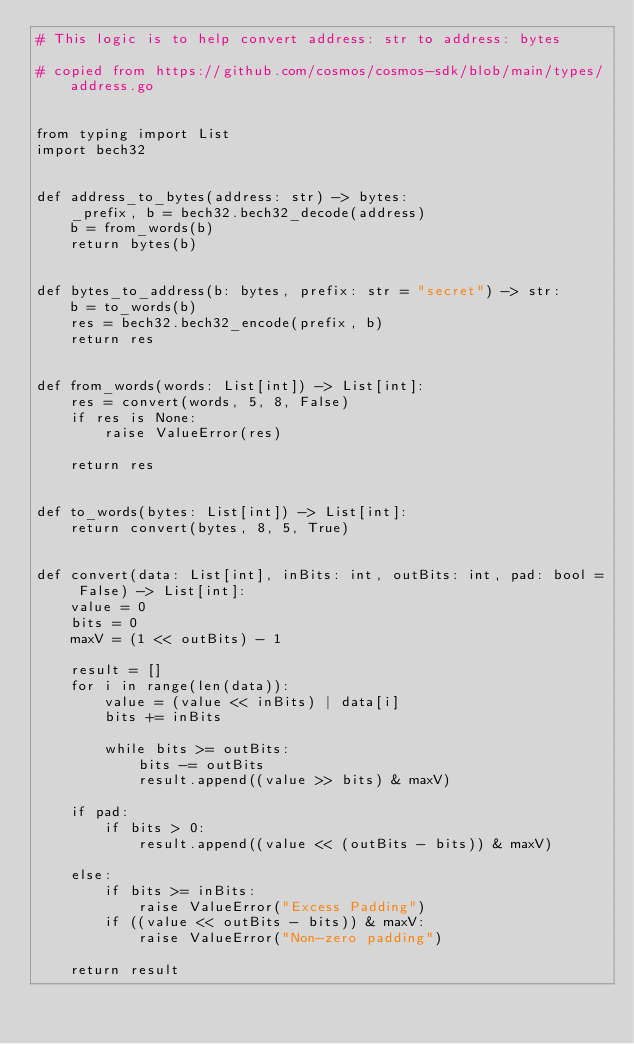<code> <loc_0><loc_0><loc_500><loc_500><_Python_># This logic is to help convert address: str to address: bytes

# copied from https://github.com/cosmos/cosmos-sdk/blob/main/types/address.go


from typing import List
import bech32


def address_to_bytes(address: str) -> bytes:
    _prefix, b = bech32.bech32_decode(address)
    b = from_words(b)
    return bytes(b)


def bytes_to_address(b: bytes, prefix: str = "secret") -> str:
    b = to_words(b)
    res = bech32.bech32_encode(prefix, b)
    return res


def from_words(words: List[int]) -> List[int]:
    res = convert(words, 5, 8, False)
    if res is None:
        raise ValueError(res)

    return res


def to_words(bytes: List[int]) -> List[int]:
    return convert(bytes, 8, 5, True)


def convert(data: List[int], inBits: int, outBits: int, pad: bool = False) -> List[int]:
    value = 0
    bits = 0
    maxV = (1 << outBits) - 1

    result = []
    for i in range(len(data)):
        value = (value << inBits) | data[i]
        bits += inBits

        while bits >= outBits:
            bits -= outBits
            result.append((value >> bits) & maxV)

    if pad:
        if bits > 0:
            result.append((value << (outBits - bits)) & maxV)

    else:
        if bits >= inBits:
            raise ValueError("Excess Padding")
        if ((value << outBits - bits)) & maxV:
            raise ValueError("Non-zero padding")

    return result
</code> 